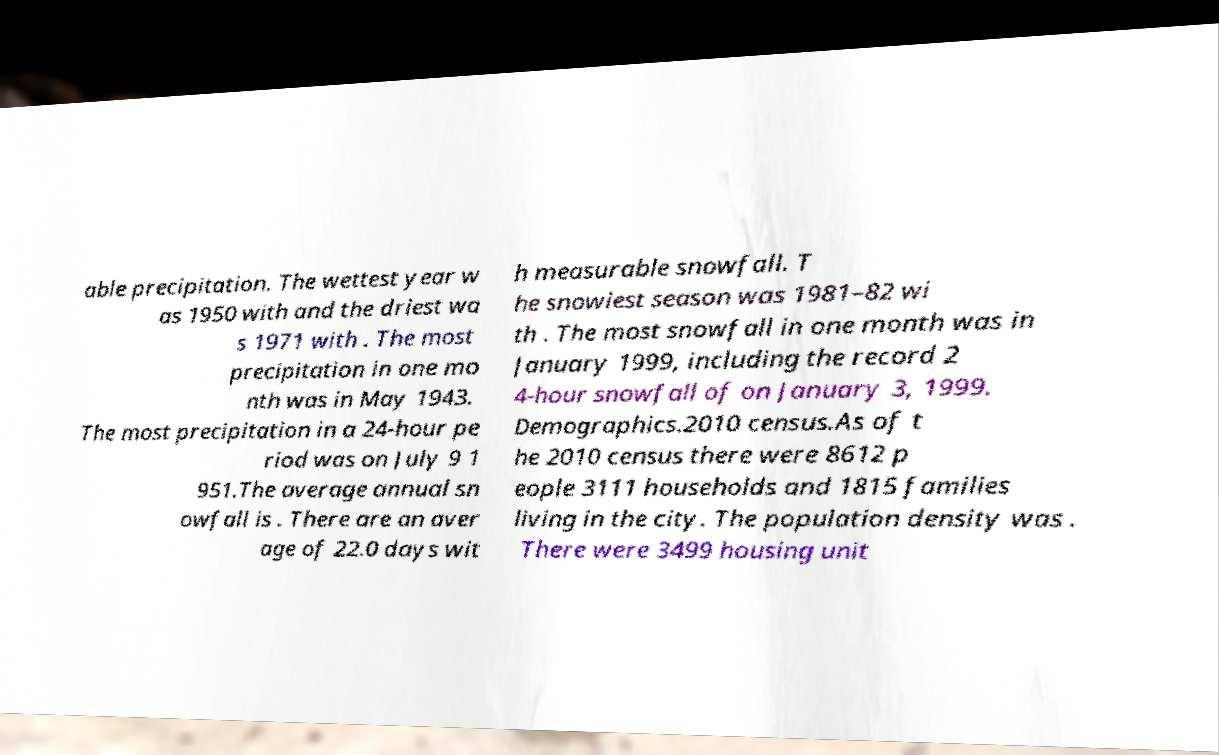What messages or text are displayed in this image? I need them in a readable, typed format. able precipitation. The wettest year w as 1950 with and the driest wa s 1971 with . The most precipitation in one mo nth was in May 1943. The most precipitation in a 24-hour pe riod was on July 9 1 951.The average annual sn owfall is . There are an aver age of 22.0 days wit h measurable snowfall. T he snowiest season was 1981–82 wi th . The most snowfall in one month was in January 1999, including the record 2 4-hour snowfall of on January 3, 1999. Demographics.2010 census.As of t he 2010 census there were 8612 p eople 3111 households and 1815 families living in the city. The population density was . There were 3499 housing unit 